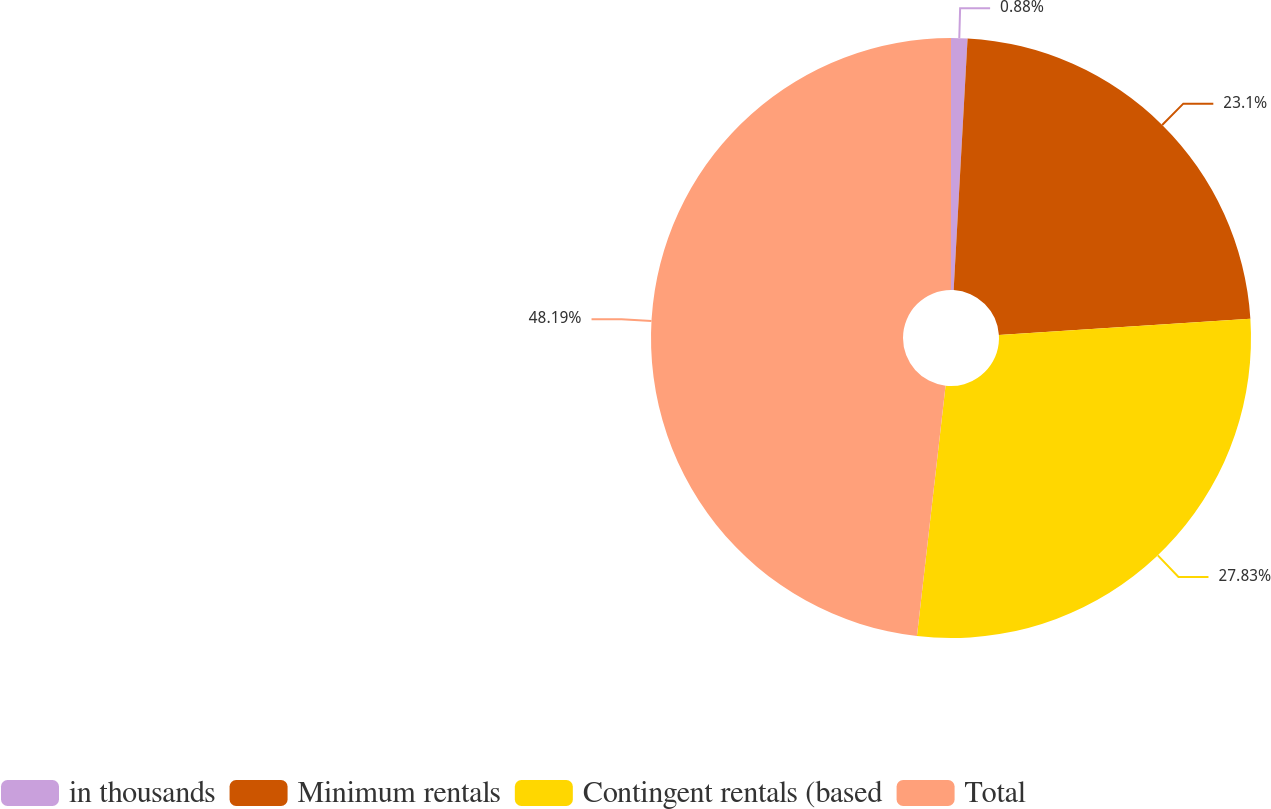Convert chart to OTSL. <chart><loc_0><loc_0><loc_500><loc_500><pie_chart><fcel>in thousands<fcel>Minimum rentals<fcel>Contingent rentals (based<fcel>Total<nl><fcel>0.88%<fcel>23.1%<fcel>27.83%<fcel>48.19%<nl></chart> 